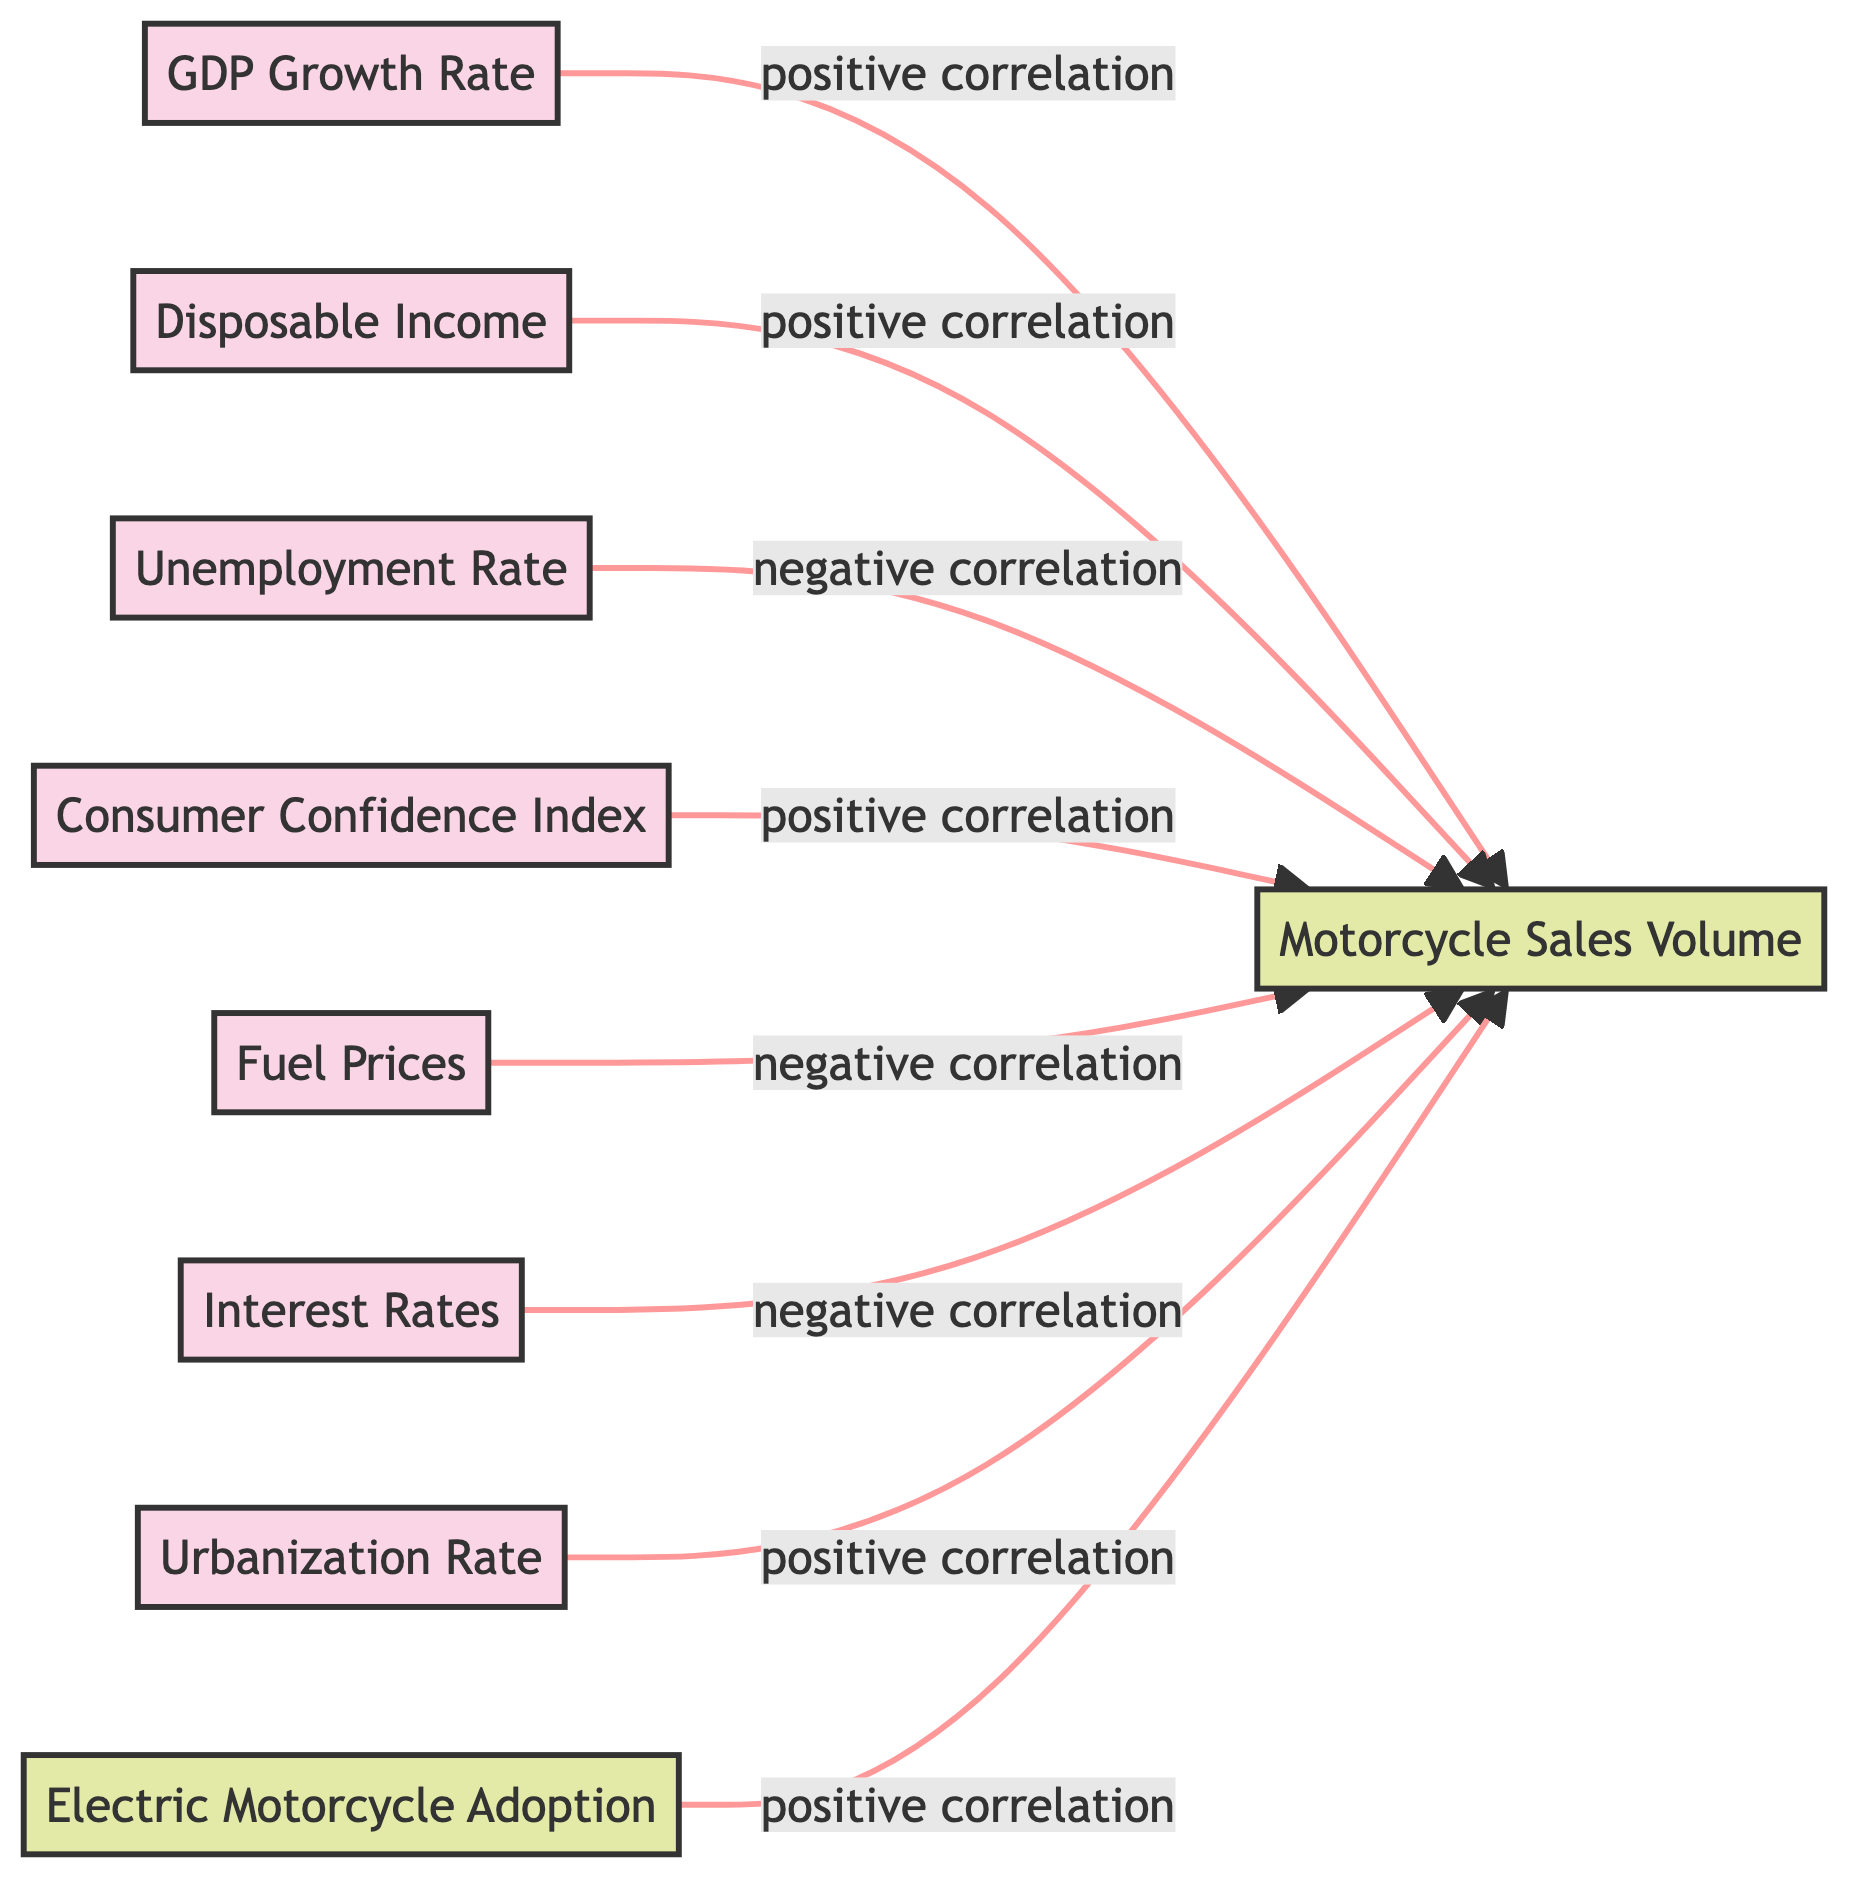What economic factor has a positive correlation with motorcycle sales volume? The diagram shows several economic factors that lead to a positive correlation with motorcycle sales volume, including GDP Growth Rate, Disposable Income, Consumer Confidence Index, Urbanization Rate, and Electric Motorcycle Adoption, where each of these factors points towards the sales volume.
Answer: GDP Growth Rate, Disposable Income, Consumer Confidence Index, Urbanization Rate, Electric Motorcycle Adoption What is the relationship between the unemployment rate and motorcycle sales volume? The unemployment rate is connected to motorcycle sales volume with a negative correlation, meaning that as the unemployment rate increases, the motorcycle sales volume tends to decrease. This is illustrated in the diagram by the arrow showing the negative relationship from the unemployment rate to the sales volume.
Answer: Negative correlation How many economic indicators are positively correlated with motorcycle sales volume? The diagram includes five economic factors that indicate a positive correlation with motorcycle sales volume. These factors can be counted from the diagram, confirming that there are five connections leading to the sales volume.
Answer: Five What is the negative correlation related to fuel prices? Fuel prices have a negative correlation with motorcycle sales volume, indicating that as fuel prices increase, the sales volume of motorcycles tends to decrease. This relationship is visually represented by an arrow pointing from fuel prices to sales volume labeled as a negative correlation.
Answer: Negative correlation Which relationship has the highest impact on increasing motorcycle sales volume? The diagram suggests several factors leading to positive correlations with motorcycle sales volume. To determine which has the highest impact requires comparing the paths, but since they are all positive correlations, any of them could theoretically lead to an increase. Based on the presence of multiple connections, GDP Growth Rate is commonly thought to be a significant factor influencing sales volume.
Answer: GDP Growth Rate 